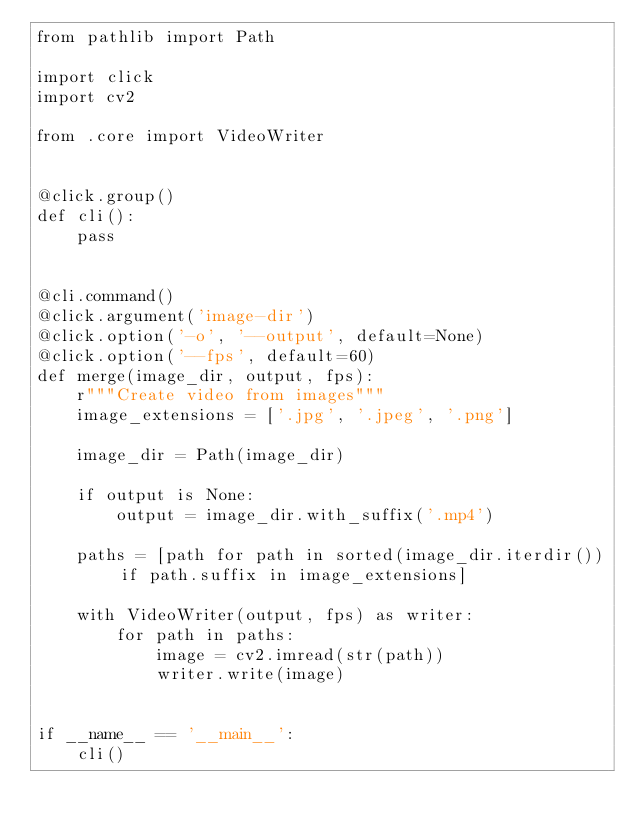<code> <loc_0><loc_0><loc_500><loc_500><_Python_>from pathlib import Path

import click
import cv2

from .core import VideoWriter


@click.group()
def cli():
    pass


@cli.command()
@click.argument('image-dir')
@click.option('-o', '--output', default=None)
@click.option('--fps', default=60)
def merge(image_dir, output, fps):
    r"""Create video from images"""
    image_extensions = ['.jpg', '.jpeg', '.png']

    image_dir = Path(image_dir)

    if output is None:
        output = image_dir.with_suffix('.mp4')

    paths = [path for path in sorted(image_dir.iterdir()) if path.suffix in image_extensions]

    with VideoWriter(output, fps) as writer:
        for path in paths:
            image = cv2.imread(str(path))
            writer.write(image)


if __name__ == '__main__':
    cli()
</code> 